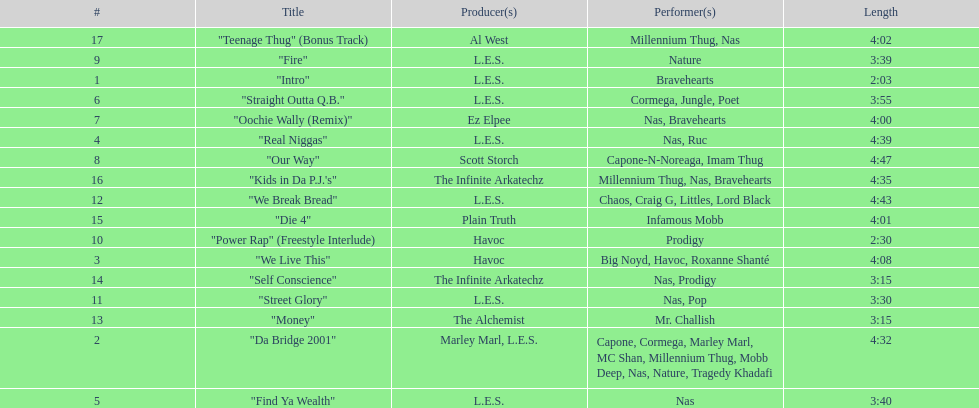What are all the song titles? "Intro", "Da Bridge 2001", "We Live This", "Real Niggas", "Find Ya Wealth", "Straight Outta Q.B.", "Oochie Wally (Remix)", "Our Way", "Fire", "Power Rap" (Freestyle Interlude), "Street Glory", "We Break Bread", "Money", "Self Conscience", "Die 4", "Kids in Da P.J.'s", "Teenage Thug" (Bonus Track). Who produced all these songs? L.E.S., Marley Marl, L.E.S., Ez Elpee, Scott Storch, Havoc, The Alchemist, The Infinite Arkatechz, Plain Truth, Al West. Of the producers, who produced the shortest song? L.E.S. How short was this producer's song? 2:03. 